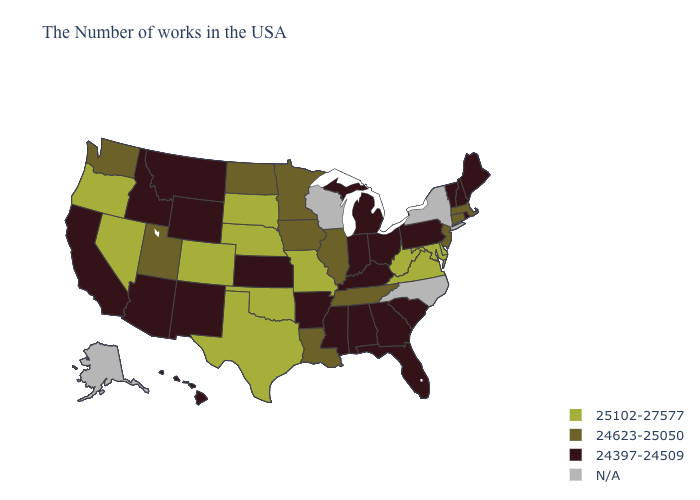Among the states that border New York , which have the highest value?
Write a very short answer. Massachusetts, Connecticut, New Jersey. What is the value of Missouri?
Concise answer only. 25102-27577. Name the states that have a value in the range N/A?
Answer briefly. New York, North Carolina, Wisconsin, Alaska. What is the highest value in the South ?
Give a very brief answer. 25102-27577. Name the states that have a value in the range 24623-25050?
Give a very brief answer. Massachusetts, Connecticut, New Jersey, Tennessee, Illinois, Louisiana, Minnesota, Iowa, North Dakota, Utah, Washington. Does the map have missing data?
Short answer required. Yes. What is the value of Kentucky?
Write a very short answer. 24397-24509. Which states have the lowest value in the Northeast?
Give a very brief answer. Maine, Rhode Island, New Hampshire, Vermont, Pennsylvania. Among the states that border New Mexico , which have the lowest value?
Be succinct. Arizona. Name the states that have a value in the range N/A?
Keep it brief. New York, North Carolina, Wisconsin, Alaska. What is the highest value in states that border Delaware?
Quick response, please. 25102-27577. What is the value of Missouri?
Keep it brief. 25102-27577. What is the value of Texas?
Keep it brief. 25102-27577. What is the highest value in the USA?
Keep it brief. 25102-27577. Name the states that have a value in the range 25102-27577?
Write a very short answer. Delaware, Maryland, Virginia, West Virginia, Missouri, Nebraska, Oklahoma, Texas, South Dakota, Colorado, Nevada, Oregon. 